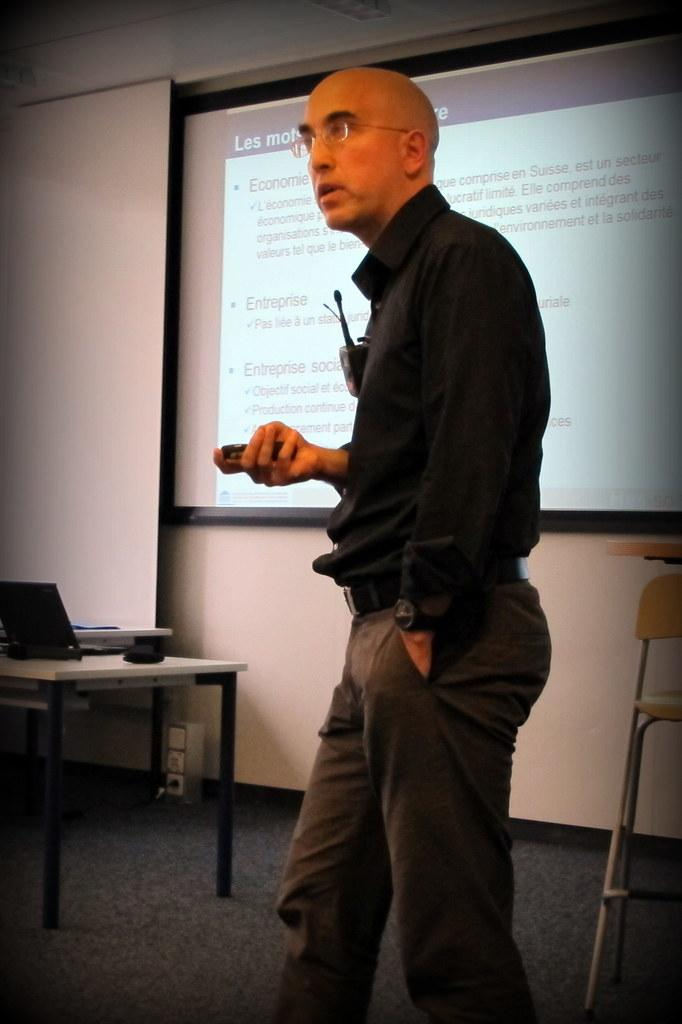Who is present in the image? There is a guy in the image. What is the guy holding in his hand? The guy is holding an electronic device in his hand. What can be seen in the background of the image? There is a screen visible in the background of the image. What type of quill is the guy using to write on the top of the design in the image? There is no quill or design present in the image. The guy is holding an electronic device, not a quill. 